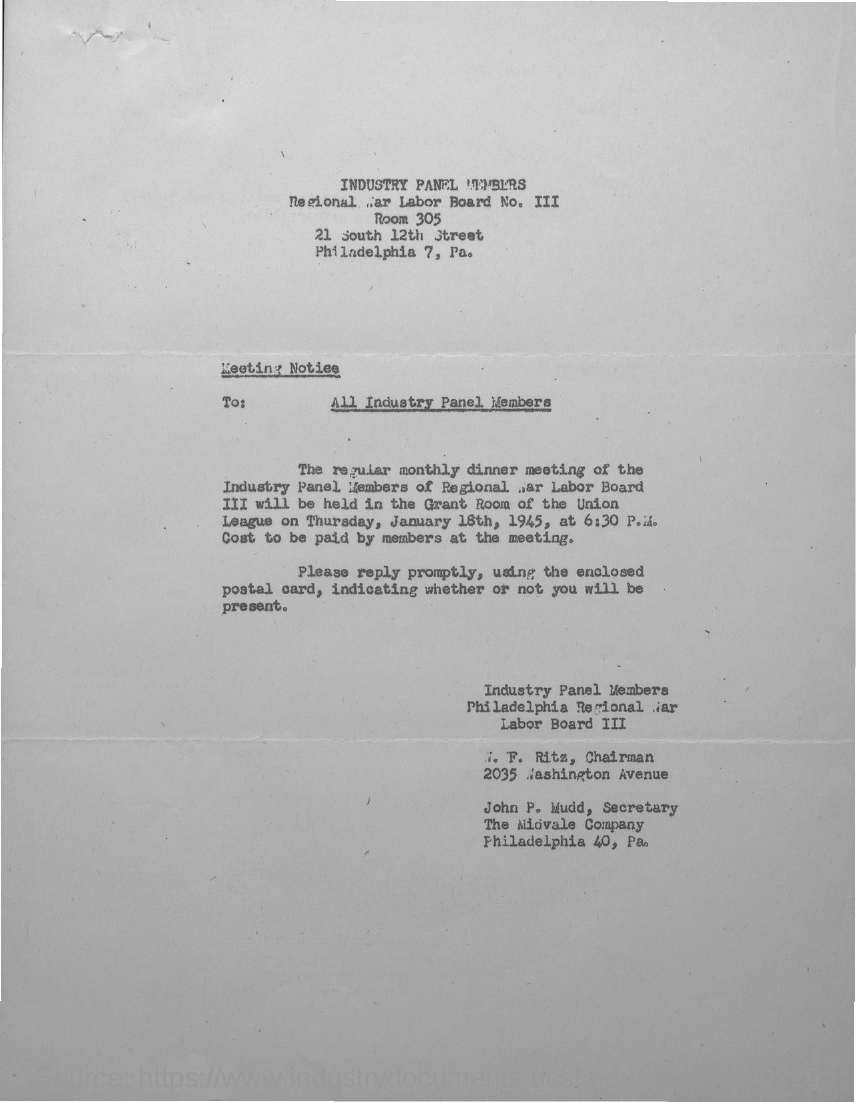Give some essential details in this illustration. The meeting notice is addressed to all members of the Industry Panel. 